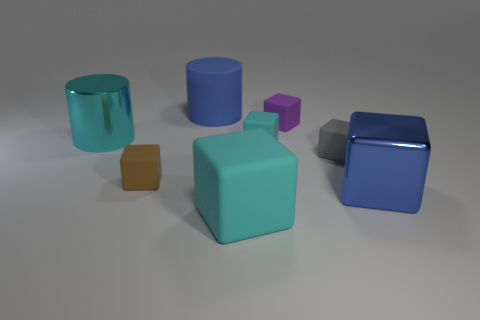Add 1 tiny purple matte objects. How many objects exist? 9 Subtract all large blue cubes. How many cubes are left? 5 Subtract all cyan cylinders. How many cyan blocks are left? 2 Subtract all cyan blocks. How many blocks are left? 4 Subtract all blocks. How many objects are left? 2 Subtract all cyan cylinders. Subtract all purple balls. How many cylinders are left? 1 Subtract all big metal cubes. Subtract all cubes. How many objects are left? 1 Add 7 large rubber cylinders. How many large rubber cylinders are left? 8 Add 2 big cyan cubes. How many big cyan cubes exist? 3 Subtract 0 gray cylinders. How many objects are left? 8 